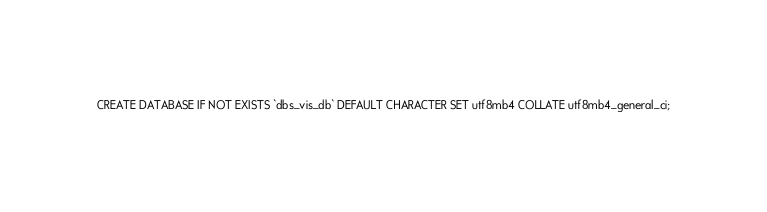<code> <loc_0><loc_0><loc_500><loc_500><_SQL_>CREATE DATABASE IF NOT EXISTS `dbs_vis_db` DEFAULT CHARACTER SET utf8mb4 COLLATE utf8mb4_general_ci;</code> 